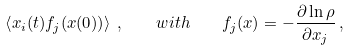<formula> <loc_0><loc_0><loc_500><loc_500>\left \langle x _ { i } ( t ) f _ { j } ( { x } ( 0 ) ) \right \rangle \, , \quad w i t h \quad f _ { j } ( { x } ) = - \frac { \partial \ln \rho } { \partial x _ { j } } \, ,</formula> 